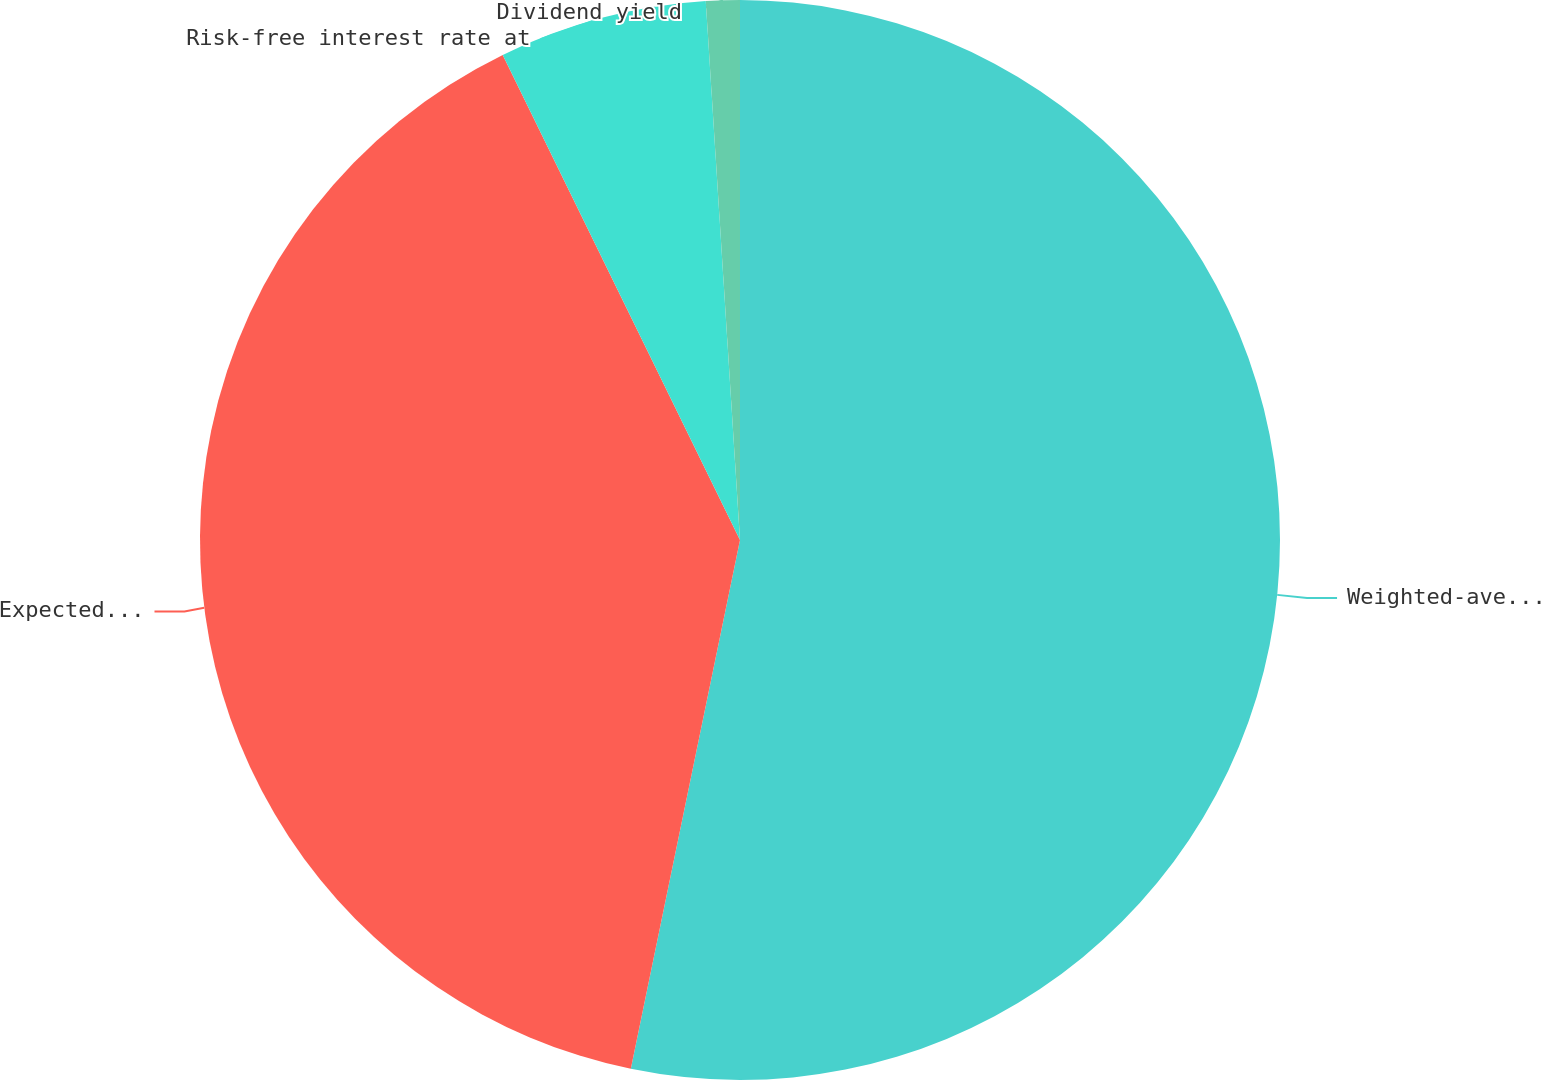Convert chart to OTSL. <chart><loc_0><loc_0><loc_500><loc_500><pie_chart><fcel>Weighted-average fair value at<fcel>Expected volatility<fcel>Risk-free interest rate at<fcel>Dividend yield<nl><fcel>53.24%<fcel>39.52%<fcel>6.23%<fcel>1.01%<nl></chart> 